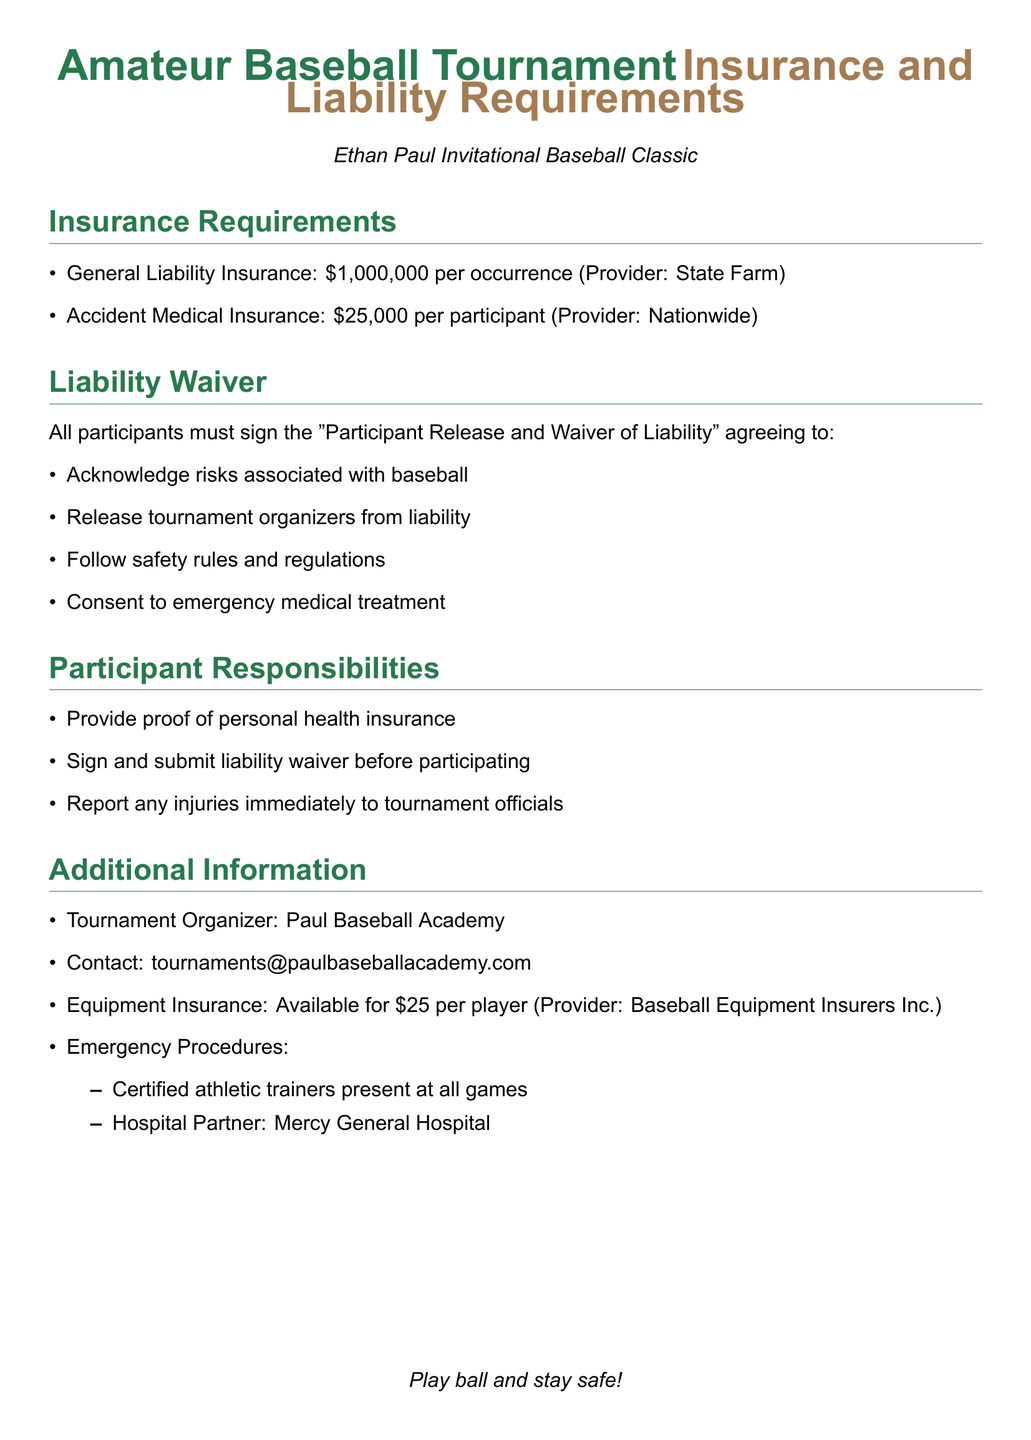what is the general liability insurance coverage amount? The document specifies that the general liability insurance coverage amount is mentioned under the insurance requirements.
Answer: $1,000,000 what is the accident medical insurance coverage per participant? The document states the coverage amount for accident medical insurance listed under the insurance requirements.
Answer: $25,000 who is the provider for accident medical insurance? The provider for accident medical insurance is indicated in the insurance requirements section.
Answer: Nationwide what must participants provide proof of before participating? The document outlines participant responsibilities that specify what must be provided before participation.
Answer: personal health insurance what do participants consent to in the liability waiver? The liability waiver section outlines what participants must agree to, including a specific aspect regarding medical treatment.
Answer: emergency medical treatment what organization is responsible for organizing the tournament? The document includes an additional information section that identifies the tournament organizer.
Answer: Paul Baseball Academy how much does equipment insurance cost per player? The document provides information on the cost of equipment insurance in the additional information section.
Answer: $25 who should injuries be reported to? The responsibilities of participants in the document specify who to report injuries to, mentioned in the participant responsibilities section.
Answer: tournament officials 